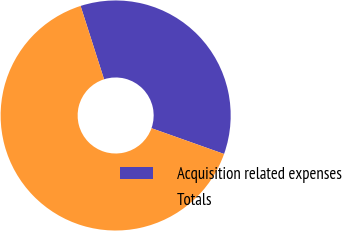<chart> <loc_0><loc_0><loc_500><loc_500><pie_chart><fcel>Acquisition related expenses<fcel>Totals<nl><fcel>35.36%<fcel>64.64%<nl></chart> 